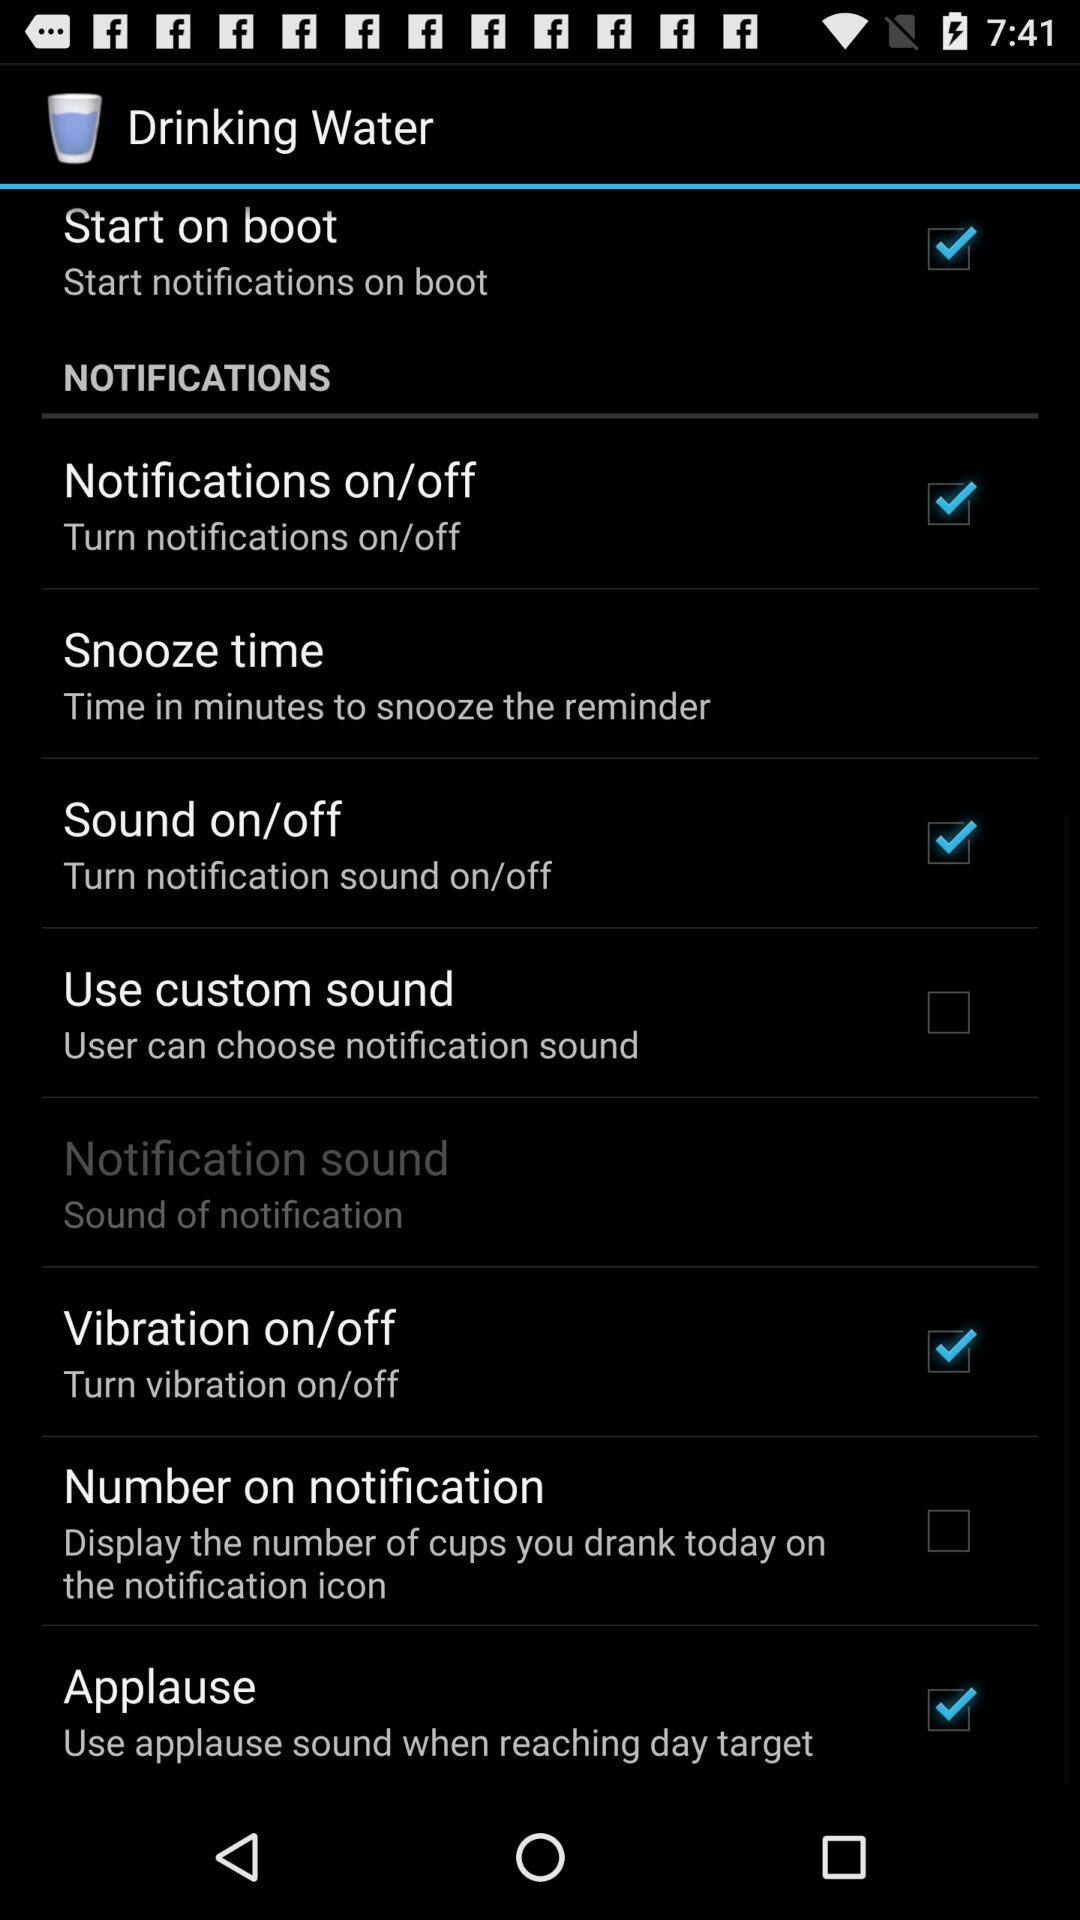What is the status of "Start on boot"? The status of "Start on boot" is "on". 